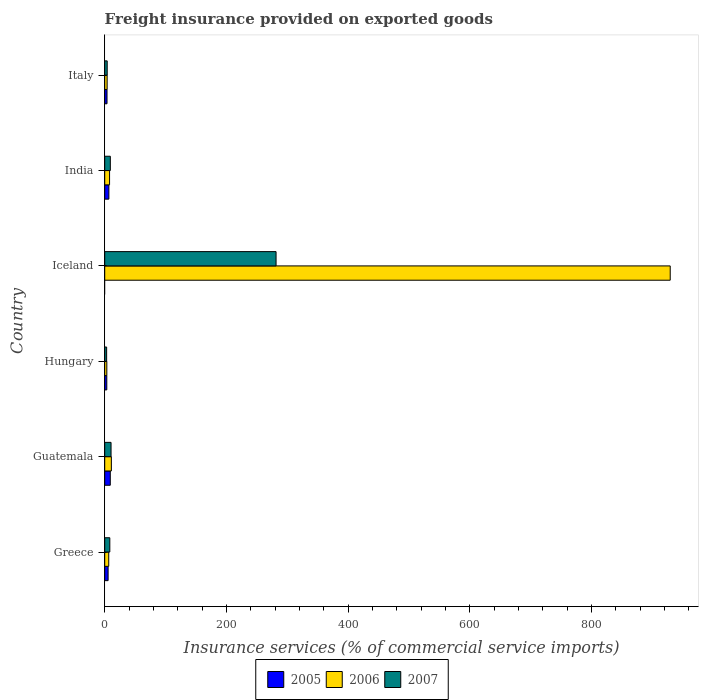How many groups of bars are there?
Offer a terse response. 6. Are the number of bars per tick equal to the number of legend labels?
Keep it short and to the point. No. Are the number of bars on each tick of the Y-axis equal?
Provide a short and direct response. No. How many bars are there on the 2nd tick from the top?
Keep it short and to the point. 3. How many bars are there on the 5th tick from the bottom?
Offer a very short reply. 3. What is the label of the 5th group of bars from the top?
Your response must be concise. Guatemala. In how many cases, is the number of bars for a given country not equal to the number of legend labels?
Offer a very short reply. 1. What is the freight insurance provided on exported goods in 2006 in Guatemala?
Your answer should be compact. 10.92. Across all countries, what is the maximum freight insurance provided on exported goods in 2006?
Your answer should be compact. 929.6. In which country was the freight insurance provided on exported goods in 2007 maximum?
Ensure brevity in your answer.  Iceland. What is the total freight insurance provided on exported goods in 2006 in the graph?
Provide a succinct answer. 962.52. What is the difference between the freight insurance provided on exported goods in 2007 in India and that in Italy?
Provide a short and direct response. 5.14. What is the difference between the freight insurance provided on exported goods in 2006 in Italy and the freight insurance provided on exported goods in 2007 in Hungary?
Make the answer very short. 0.82. What is the average freight insurance provided on exported goods in 2005 per country?
Your response must be concise. 4.8. What is the difference between the freight insurance provided on exported goods in 2007 and freight insurance provided on exported goods in 2006 in India?
Give a very brief answer. 1.25. In how many countries, is the freight insurance provided on exported goods in 2007 greater than 360 %?
Your answer should be very brief. 0. What is the ratio of the freight insurance provided on exported goods in 2005 in Greece to that in India?
Provide a short and direct response. 0.82. Is the freight insurance provided on exported goods in 2006 in Greece less than that in India?
Keep it short and to the point. Yes. What is the difference between the highest and the second highest freight insurance provided on exported goods in 2005?
Give a very brief answer. 2.29. What is the difference between the highest and the lowest freight insurance provided on exported goods in 2007?
Your answer should be compact. 278.52. In how many countries, is the freight insurance provided on exported goods in 2005 greater than the average freight insurance provided on exported goods in 2005 taken over all countries?
Offer a terse response. 3. Are all the bars in the graph horizontal?
Your answer should be very brief. Yes. Does the graph contain any zero values?
Give a very brief answer. Yes. Where does the legend appear in the graph?
Give a very brief answer. Bottom center. How are the legend labels stacked?
Offer a very short reply. Horizontal. What is the title of the graph?
Your answer should be compact. Freight insurance provided on exported goods. Does "1973" appear as one of the legend labels in the graph?
Make the answer very short. No. What is the label or title of the X-axis?
Ensure brevity in your answer.  Insurance services (% of commercial service imports). What is the label or title of the Y-axis?
Offer a terse response. Country. What is the Insurance services (% of commercial service imports) of 2005 in Greece?
Your answer should be very brief. 5.59. What is the Insurance services (% of commercial service imports) of 2006 in Greece?
Make the answer very short. 6.61. What is the Insurance services (% of commercial service imports) of 2007 in Greece?
Give a very brief answer. 8.37. What is the Insurance services (% of commercial service imports) of 2005 in Guatemala?
Provide a succinct answer. 9.14. What is the Insurance services (% of commercial service imports) in 2006 in Guatemala?
Your answer should be compact. 10.92. What is the Insurance services (% of commercial service imports) of 2007 in Guatemala?
Offer a terse response. 10.41. What is the Insurance services (% of commercial service imports) of 2005 in Hungary?
Your answer should be compact. 3.41. What is the Insurance services (% of commercial service imports) in 2006 in Hungary?
Your response must be concise. 3.46. What is the Insurance services (% of commercial service imports) of 2007 in Hungary?
Offer a very short reply. 3.16. What is the Insurance services (% of commercial service imports) of 2005 in Iceland?
Your answer should be compact. 0. What is the Insurance services (% of commercial service imports) of 2006 in Iceland?
Provide a short and direct response. 929.6. What is the Insurance services (% of commercial service imports) of 2007 in Iceland?
Keep it short and to the point. 281.68. What is the Insurance services (% of commercial service imports) in 2005 in India?
Offer a very short reply. 6.85. What is the Insurance services (% of commercial service imports) of 2006 in India?
Offer a very short reply. 7.96. What is the Insurance services (% of commercial service imports) in 2007 in India?
Ensure brevity in your answer.  9.21. What is the Insurance services (% of commercial service imports) in 2005 in Italy?
Your answer should be compact. 3.79. What is the Insurance services (% of commercial service imports) of 2006 in Italy?
Ensure brevity in your answer.  3.97. What is the Insurance services (% of commercial service imports) in 2007 in Italy?
Make the answer very short. 4.07. Across all countries, what is the maximum Insurance services (% of commercial service imports) in 2005?
Make the answer very short. 9.14. Across all countries, what is the maximum Insurance services (% of commercial service imports) of 2006?
Your answer should be very brief. 929.6. Across all countries, what is the maximum Insurance services (% of commercial service imports) of 2007?
Your response must be concise. 281.68. Across all countries, what is the minimum Insurance services (% of commercial service imports) of 2005?
Your answer should be compact. 0. Across all countries, what is the minimum Insurance services (% of commercial service imports) in 2006?
Provide a succinct answer. 3.46. Across all countries, what is the minimum Insurance services (% of commercial service imports) in 2007?
Provide a succinct answer. 3.16. What is the total Insurance services (% of commercial service imports) in 2005 in the graph?
Provide a short and direct response. 28.78. What is the total Insurance services (% of commercial service imports) of 2006 in the graph?
Ensure brevity in your answer.  962.52. What is the total Insurance services (% of commercial service imports) of 2007 in the graph?
Your answer should be very brief. 316.9. What is the difference between the Insurance services (% of commercial service imports) in 2005 in Greece and that in Guatemala?
Keep it short and to the point. -3.55. What is the difference between the Insurance services (% of commercial service imports) in 2006 in Greece and that in Guatemala?
Keep it short and to the point. -4.31. What is the difference between the Insurance services (% of commercial service imports) of 2007 in Greece and that in Guatemala?
Give a very brief answer. -2.04. What is the difference between the Insurance services (% of commercial service imports) in 2005 in Greece and that in Hungary?
Make the answer very short. 2.17. What is the difference between the Insurance services (% of commercial service imports) of 2006 in Greece and that in Hungary?
Keep it short and to the point. 3.15. What is the difference between the Insurance services (% of commercial service imports) of 2007 in Greece and that in Hungary?
Offer a terse response. 5.21. What is the difference between the Insurance services (% of commercial service imports) in 2006 in Greece and that in Iceland?
Provide a succinct answer. -922.99. What is the difference between the Insurance services (% of commercial service imports) of 2007 in Greece and that in Iceland?
Give a very brief answer. -273.3. What is the difference between the Insurance services (% of commercial service imports) in 2005 in Greece and that in India?
Give a very brief answer. -1.26. What is the difference between the Insurance services (% of commercial service imports) of 2006 in Greece and that in India?
Give a very brief answer. -1.36. What is the difference between the Insurance services (% of commercial service imports) in 2007 in Greece and that in India?
Give a very brief answer. -0.84. What is the difference between the Insurance services (% of commercial service imports) in 2005 in Greece and that in Italy?
Offer a terse response. 1.8. What is the difference between the Insurance services (% of commercial service imports) of 2006 in Greece and that in Italy?
Offer a very short reply. 2.63. What is the difference between the Insurance services (% of commercial service imports) in 2007 in Greece and that in Italy?
Provide a short and direct response. 4.3. What is the difference between the Insurance services (% of commercial service imports) of 2005 in Guatemala and that in Hungary?
Provide a succinct answer. 5.73. What is the difference between the Insurance services (% of commercial service imports) in 2006 in Guatemala and that in Hungary?
Ensure brevity in your answer.  7.46. What is the difference between the Insurance services (% of commercial service imports) in 2007 in Guatemala and that in Hungary?
Your response must be concise. 7.25. What is the difference between the Insurance services (% of commercial service imports) of 2006 in Guatemala and that in Iceland?
Provide a succinct answer. -918.68. What is the difference between the Insurance services (% of commercial service imports) in 2007 in Guatemala and that in Iceland?
Offer a very short reply. -271.27. What is the difference between the Insurance services (% of commercial service imports) in 2005 in Guatemala and that in India?
Keep it short and to the point. 2.29. What is the difference between the Insurance services (% of commercial service imports) in 2006 in Guatemala and that in India?
Your answer should be very brief. 2.96. What is the difference between the Insurance services (% of commercial service imports) of 2007 in Guatemala and that in India?
Provide a short and direct response. 1.2. What is the difference between the Insurance services (% of commercial service imports) of 2005 in Guatemala and that in Italy?
Offer a terse response. 5.35. What is the difference between the Insurance services (% of commercial service imports) of 2006 in Guatemala and that in Italy?
Your answer should be compact. 6.95. What is the difference between the Insurance services (% of commercial service imports) of 2007 in Guatemala and that in Italy?
Provide a succinct answer. 6.34. What is the difference between the Insurance services (% of commercial service imports) in 2006 in Hungary and that in Iceland?
Your answer should be compact. -926.14. What is the difference between the Insurance services (% of commercial service imports) of 2007 in Hungary and that in Iceland?
Make the answer very short. -278.52. What is the difference between the Insurance services (% of commercial service imports) of 2005 in Hungary and that in India?
Offer a terse response. -3.44. What is the difference between the Insurance services (% of commercial service imports) in 2006 in Hungary and that in India?
Your answer should be very brief. -4.5. What is the difference between the Insurance services (% of commercial service imports) of 2007 in Hungary and that in India?
Keep it short and to the point. -6.05. What is the difference between the Insurance services (% of commercial service imports) of 2005 in Hungary and that in Italy?
Provide a succinct answer. -0.37. What is the difference between the Insurance services (% of commercial service imports) of 2006 in Hungary and that in Italy?
Your answer should be compact. -0.51. What is the difference between the Insurance services (% of commercial service imports) of 2007 in Hungary and that in Italy?
Make the answer very short. -0.92. What is the difference between the Insurance services (% of commercial service imports) in 2006 in Iceland and that in India?
Make the answer very short. 921.63. What is the difference between the Insurance services (% of commercial service imports) in 2007 in Iceland and that in India?
Offer a very short reply. 272.46. What is the difference between the Insurance services (% of commercial service imports) in 2006 in Iceland and that in Italy?
Make the answer very short. 925.62. What is the difference between the Insurance services (% of commercial service imports) in 2007 in Iceland and that in Italy?
Provide a succinct answer. 277.6. What is the difference between the Insurance services (% of commercial service imports) in 2005 in India and that in Italy?
Your answer should be compact. 3.06. What is the difference between the Insurance services (% of commercial service imports) in 2006 in India and that in Italy?
Offer a terse response. 3.99. What is the difference between the Insurance services (% of commercial service imports) in 2007 in India and that in Italy?
Offer a very short reply. 5.14. What is the difference between the Insurance services (% of commercial service imports) of 2005 in Greece and the Insurance services (% of commercial service imports) of 2006 in Guatemala?
Ensure brevity in your answer.  -5.33. What is the difference between the Insurance services (% of commercial service imports) in 2005 in Greece and the Insurance services (% of commercial service imports) in 2007 in Guatemala?
Make the answer very short. -4.82. What is the difference between the Insurance services (% of commercial service imports) of 2006 in Greece and the Insurance services (% of commercial service imports) of 2007 in Guatemala?
Offer a very short reply. -3.81. What is the difference between the Insurance services (% of commercial service imports) in 2005 in Greece and the Insurance services (% of commercial service imports) in 2006 in Hungary?
Make the answer very short. 2.13. What is the difference between the Insurance services (% of commercial service imports) in 2005 in Greece and the Insurance services (% of commercial service imports) in 2007 in Hungary?
Your response must be concise. 2.43. What is the difference between the Insurance services (% of commercial service imports) of 2006 in Greece and the Insurance services (% of commercial service imports) of 2007 in Hungary?
Your answer should be very brief. 3.45. What is the difference between the Insurance services (% of commercial service imports) of 2005 in Greece and the Insurance services (% of commercial service imports) of 2006 in Iceland?
Offer a terse response. -924.01. What is the difference between the Insurance services (% of commercial service imports) in 2005 in Greece and the Insurance services (% of commercial service imports) in 2007 in Iceland?
Provide a succinct answer. -276.09. What is the difference between the Insurance services (% of commercial service imports) in 2006 in Greece and the Insurance services (% of commercial service imports) in 2007 in Iceland?
Your answer should be compact. -275.07. What is the difference between the Insurance services (% of commercial service imports) in 2005 in Greece and the Insurance services (% of commercial service imports) in 2006 in India?
Provide a short and direct response. -2.37. What is the difference between the Insurance services (% of commercial service imports) of 2005 in Greece and the Insurance services (% of commercial service imports) of 2007 in India?
Make the answer very short. -3.62. What is the difference between the Insurance services (% of commercial service imports) of 2006 in Greece and the Insurance services (% of commercial service imports) of 2007 in India?
Keep it short and to the point. -2.61. What is the difference between the Insurance services (% of commercial service imports) in 2005 in Greece and the Insurance services (% of commercial service imports) in 2006 in Italy?
Offer a very short reply. 1.61. What is the difference between the Insurance services (% of commercial service imports) in 2005 in Greece and the Insurance services (% of commercial service imports) in 2007 in Italy?
Provide a short and direct response. 1.51. What is the difference between the Insurance services (% of commercial service imports) in 2006 in Greece and the Insurance services (% of commercial service imports) in 2007 in Italy?
Provide a short and direct response. 2.53. What is the difference between the Insurance services (% of commercial service imports) in 2005 in Guatemala and the Insurance services (% of commercial service imports) in 2006 in Hungary?
Provide a short and direct response. 5.68. What is the difference between the Insurance services (% of commercial service imports) of 2005 in Guatemala and the Insurance services (% of commercial service imports) of 2007 in Hungary?
Your response must be concise. 5.98. What is the difference between the Insurance services (% of commercial service imports) of 2006 in Guatemala and the Insurance services (% of commercial service imports) of 2007 in Hungary?
Your response must be concise. 7.76. What is the difference between the Insurance services (% of commercial service imports) in 2005 in Guatemala and the Insurance services (% of commercial service imports) in 2006 in Iceland?
Your response must be concise. -920.46. What is the difference between the Insurance services (% of commercial service imports) in 2005 in Guatemala and the Insurance services (% of commercial service imports) in 2007 in Iceland?
Make the answer very short. -272.54. What is the difference between the Insurance services (% of commercial service imports) in 2006 in Guatemala and the Insurance services (% of commercial service imports) in 2007 in Iceland?
Ensure brevity in your answer.  -270.76. What is the difference between the Insurance services (% of commercial service imports) of 2005 in Guatemala and the Insurance services (% of commercial service imports) of 2006 in India?
Offer a very short reply. 1.18. What is the difference between the Insurance services (% of commercial service imports) in 2005 in Guatemala and the Insurance services (% of commercial service imports) in 2007 in India?
Your answer should be compact. -0.07. What is the difference between the Insurance services (% of commercial service imports) in 2006 in Guatemala and the Insurance services (% of commercial service imports) in 2007 in India?
Your answer should be compact. 1.71. What is the difference between the Insurance services (% of commercial service imports) in 2005 in Guatemala and the Insurance services (% of commercial service imports) in 2006 in Italy?
Make the answer very short. 5.17. What is the difference between the Insurance services (% of commercial service imports) in 2005 in Guatemala and the Insurance services (% of commercial service imports) in 2007 in Italy?
Your answer should be compact. 5.07. What is the difference between the Insurance services (% of commercial service imports) of 2006 in Guatemala and the Insurance services (% of commercial service imports) of 2007 in Italy?
Ensure brevity in your answer.  6.85. What is the difference between the Insurance services (% of commercial service imports) of 2005 in Hungary and the Insurance services (% of commercial service imports) of 2006 in Iceland?
Ensure brevity in your answer.  -926.18. What is the difference between the Insurance services (% of commercial service imports) in 2005 in Hungary and the Insurance services (% of commercial service imports) in 2007 in Iceland?
Provide a short and direct response. -278.26. What is the difference between the Insurance services (% of commercial service imports) of 2006 in Hungary and the Insurance services (% of commercial service imports) of 2007 in Iceland?
Offer a terse response. -278.22. What is the difference between the Insurance services (% of commercial service imports) in 2005 in Hungary and the Insurance services (% of commercial service imports) in 2006 in India?
Give a very brief answer. -4.55. What is the difference between the Insurance services (% of commercial service imports) of 2005 in Hungary and the Insurance services (% of commercial service imports) of 2007 in India?
Provide a short and direct response. -5.8. What is the difference between the Insurance services (% of commercial service imports) of 2006 in Hungary and the Insurance services (% of commercial service imports) of 2007 in India?
Your response must be concise. -5.75. What is the difference between the Insurance services (% of commercial service imports) in 2005 in Hungary and the Insurance services (% of commercial service imports) in 2006 in Italy?
Your response must be concise. -0.56. What is the difference between the Insurance services (% of commercial service imports) of 2005 in Hungary and the Insurance services (% of commercial service imports) of 2007 in Italy?
Keep it short and to the point. -0.66. What is the difference between the Insurance services (% of commercial service imports) of 2006 in Hungary and the Insurance services (% of commercial service imports) of 2007 in Italy?
Provide a succinct answer. -0.61. What is the difference between the Insurance services (% of commercial service imports) of 2006 in Iceland and the Insurance services (% of commercial service imports) of 2007 in India?
Offer a very short reply. 920.38. What is the difference between the Insurance services (% of commercial service imports) of 2006 in Iceland and the Insurance services (% of commercial service imports) of 2007 in Italy?
Provide a short and direct response. 925.52. What is the difference between the Insurance services (% of commercial service imports) of 2005 in India and the Insurance services (% of commercial service imports) of 2006 in Italy?
Make the answer very short. 2.88. What is the difference between the Insurance services (% of commercial service imports) in 2005 in India and the Insurance services (% of commercial service imports) in 2007 in Italy?
Offer a terse response. 2.78. What is the difference between the Insurance services (% of commercial service imports) in 2006 in India and the Insurance services (% of commercial service imports) in 2007 in Italy?
Your response must be concise. 3.89. What is the average Insurance services (% of commercial service imports) in 2005 per country?
Make the answer very short. 4.8. What is the average Insurance services (% of commercial service imports) in 2006 per country?
Give a very brief answer. 160.42. What is the average Insurance services (% of commercial service imports) of 2007 per country?
Your answer should be compact. 52.82. What is the difference between the Insurance services (% of commercial service imports) in 2005 and Insurance services (% of commercial service imports) in 2006 in Greece?
Make the answer very short. -1.02. What is the difference between the Insurance services (% of commercial service imports) in 2005 and Insurance services (% of commercial service imports) in 2007 in Greece?
Provide a short and direct response. -2.78. What is the difference between the Insurance services (% of commercial service imports) of 2006 and Insurance services (% of commercial service imports) of 2007 in Greece?
Provide a short and direct response. -1.77. What is the difference between the Insurance services (% of commercial service imports) in 2005 and Insurance services (% of commercial service imports) in 2006 in Guatemala?
Make the answer very short. -1.78. What is the difference between the Insurance services (% of commercial service imports) of 2005 and Insurance services (% of commercial service imports) of 2007 in Guatemala?
Offer a very short reply. -1.27. What is the difference between the Insurance services (% of commercial service imports) of 2006 and Insurance services (% of commercial service imports) of 2007 in Guatemala?
Your answer should be very brief. 0.51. What is the difference between the Insurance services (% of commercial service imports) in 2005 and Insurance services (% of commercial service imports) in 2006 in Hungary?
Make the answer very short. -0.05. What is the difference between the Insurance services (% of commercial service imports) in 2005 and Insurance services (% of commercial service imports) in 2007 in Hungary?
Provide a succinct answer. 0.26. What is the difference between the Insurance services (% of commercial service imports) in 2006 and Insurance services (% of commercial service imports) in 2007 in Hungary?
Offer a terse response. 0.3. What is the difference between the Insurance services (% of commercial service imports) in 2006 and Insurance services (% of commercial service imports) in 2007 in Iceland?
Give a very brief answer. 647.92. What is the difference between the Insurance services (% of commercial service imports) of 2005 and Insurance services (% of commercial service imports) of 2006 in India?
Your response must be concise. -1.11. What is the difference between the Insurance services (% of commercial service imports) of 2005 and Insurance services (% of commercial service imports) of 2007 in India?
Make the answer very short. -2.36. What is the difference between the Insurance services (% of commercial service imports) of 2006 and Insurance services (% of commercial service imports) of 2007 in India?
Give a very brief answer. -1.25. What is the difference between the Insurance services (% of commercial service imports) in 2005 and Insurance services (% of commercial service imports) in 2006 in Italy?
Your response must be concise. -0.19. What is the difference between the Insurance services (% of commercial service imports) in 2005 and Insurance services (% of commercial service imports) in 2007 in Italy?
Your response must be concise. -0.29. What is the difference between the Insurance services (% of commercial service imports) of 2006 and Insurance services (% of commercial service imports) of 2007 in Italy?
Keep it short and to the point. -0.1. What is the ratio of the Insurance services (% of commercial service imports) of 2005 in Greece to that in Guatemala?
Make the answer very short. 0.61. What is the ratio of the Insurance services (% of commercial service imports) of 2006 in Greece to that in Guatemala?
Your answer should be very brief. 0.6. What is the ratio of the Insurance services (% of commercial service imports) in 2007 in Greece to that in Guatemala?
Your answer should be compact. 0.8. What is the ratio of the Insurance services (% of commercial service imports) of 2005 in Greece to that in Hungary?
Give a very brief answer. 1.64. What is the ratio of the Insurance services (% of commercial service imports) in 2006 in Greece to that in Hungary?
Provide a short and direct response. 1.91. What is the ratio of the Insurance services (% of commercial service imports) in 2007 in Greece to that in Hungary?
Your answer should be very brief. 2.65. What is the ratio of the Insurance services (% of commercial service imports) of 2006 in Greece to that in Iceland?
Keep it short and to the point. 0.01. What is the ratio of the Insurance services (% of commercial service imports) of 2007 in Greece to that in Iceland?
Your answer should be compact. 0.03. What is the ratio of the Insurance services (% of commercial service imports) of 2005 in Greece to that in India?
Your answer should be compact. 0.82. What is the ratio of the Insurance services (% of commercial service imports) in 2006 in Greece to that in India?
Offer a very short reply. 0.83. What is the ratio of the Insurance services (% of commercial service imports) in 2007 in Greece to that in India?
Provide a succinct answer. 0.91. What is the ratio of the Insurance services (% of commercial service imports) of 2005 in Greece to that in Italy?
Your response must be concise. 1.48. What is the ratio of the Insurance services (% of commercial service imports) of 2006 in Greece to that in Italy?
Provide a succinct answer. 1.66. What is the ratio of the Insurance services (% of commercial service imports) in 2007 in Greece to that in Italy?
Keep it short and to the point. 2.06. What is the ratio of the Insurance services (% of commercial service imports) of 2005 in Guatemala to that in Hungary?
Your response must be concise. 2.68. What is the ratio of the Insurance services (% of commercial service imports) of 2006 in Guatemala to that in Hungary?
Offer a very short reply. 3.16. What is the ratio of the Insurance services (% of commercial service imports) in 2007 in Guatemala to that in Hungary?
Your answer should be compact. 3.3. What is the ratio of the Insurance services (% of commercial service imports) of 2006 in Guatemala to that in Iceland?
Ensure brevity in your answer.  0.01. What is the ratio of the Insurance services (% of commercial service imports) in 2007 in Guatemala to that in Iceland?
Your response must be concise. 0.04. What is the ratio of the Insurance services (% of commercial service imports) of 2005 in Guatemala to that in India?
Keep it short and to the point. 1.33. What is the ratio of the Insurance services (% of commercial service imports) of 2006 in Guatemala to that in India?
Provide a short and direct response. 1.37. What is the ratio of the Insurance services (% of commercial service imports) in 2007 in Guatemala to that in India?
Provide a short and direct response. 1.13. What is the ratio of the Insurance services (% of commercial service imports) of 2005 in Guatemala to that in Italy?
Your response must be concise. 2.41. What is the ratio of the Insurance services (% of commercial service imports) in 2006 in Guatemala to that in Italy?
Your answer should be compact. 2.75. What is the ratio of the Insurance services (% of commercial service imports) of 2007 in Guatemala to that in Italy?
Your answer should be compact. 2.56. What is the ratio of the Insurance services (% of commercial service imports) in 2006 in Hungary to that in Iceland?
Offer a terse response. 0. What is the ratio of the Insurance services (% of commercial service imports) in 2007 in Hungary to that in Iceland?
Ensure brevity in your answer.  0.01. What is the ratio of the Insurance services (% of commercial service imports) of 2005 in Hungary to that in India?
Your response must be concise. 0.5. What is the ratio of the Insurance services (% of commercial service imports) of 2006 in Hungary to that in India?
Make the answer very short. 0.43. What is the ratio of the Insurance services (% of commercial service imports) in 2007 in Hungary to that in India?
Give a very brief answer. 0.34. What is the ratio of the Insurance services (% of commercial service imports) of 2005 in Hungary to that in Italy?
Give a very brief answer. 0.9. What is the ratio of the Insurance services (% of commercial service imports) in 2006 in Hungary to that in Italy?
Provide a short and direct response. 0.87. What is the ratio of the Insurance services (% of commercial service imports) in 2007 in Hungary to that in Italy?
Ensure brevity in your answer.  0.78. What is the ratio of the Insurance services (% of commercial service imports) of 2006 in Iceland to that in India?
Keep it short and to the point. 116.76. What is the ratio of the Insurance services (% of commercial service imports) of 2007 in Iceland to that in India?
Offer a very short reply. 30.58. What is the ratio of the Insurance services (% of commercial service imports) in 2006 in Iceland to that in Italy?
Your answer should be very brief. 233.89. What is the ratio of the Insurance services (% of commercial service imports) of 2007 in Iceland to that in Italy?
Provide a short and direct response. 69.15. What is the ratio of the Insurance services (% of commercial service imports) of 2005 in India to that in Italy?
Make the answer very short. 1.81. What is the ratio of the Insurance services (% of commercial service imports) in 2006 in India to that in Italy?
Ensure brevity in your answer.  2. What is the ratio of the Insurance services (% of commercial service imports) in 2007 in India to that in Italy?
Provide a succinct answer. 2.26. What is the difference between the highest and the second highest Insurance services (% of commercial service imports) in 2005?
Your answer should be compact. 2.29. What is the difference between the highest and the second highest Insurance services (% of commercial service imports) of 2006?
Offer a very short reply. 918.68. What is the difference between the highest and the second highest Insurance services (% of commercial service imports) of 2007?
Offer a very short reply. 271.27. What is the difference between the highest and the lowest Insurance services (% of commercial service imports) in 2005?
Ensure brevity in your answer.  9.14. What is the difference between the highest and the lowest Insurance services (% of commercial service imports) of 2006?
Offer a terse response. 926.14. What is the difference between the highest and the lowest Insurance services (% of commercial service imports) in 2007?
Keep it short and to the point. 278.52. 